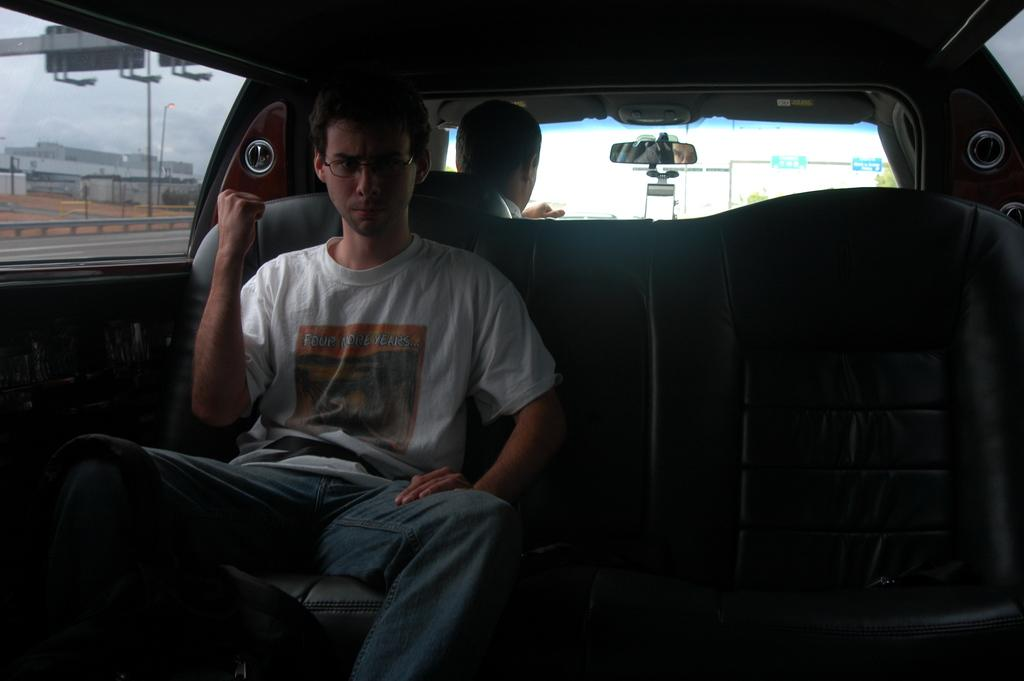Who is present in the image? There is a man in the image. What is the man doing in the image? The man is inside a vehicle. Can you describe the man's appearance? The man is wearing spectacles. What can be seen in the background of the image? The sky is visible in the background of the image. What type of instrument does the man play in the image? There is no instrument present in the image, and the man is not shown playing any instrument. 